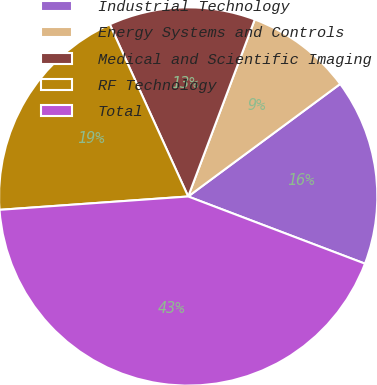Convert chart. <chart><loc_0><loc_0><loc_500><loc_500><pie_chart><fcel>Industrial Technology<fcel>Energy Systems and Controls<fcel>Medical and Scientific Imaging<fcel>RF Technology<fcel>Total<nl><fcel>15.92%<fcel>9.13%<fcel>12.53%<fcel>19.32%<fcel>43.09%<nl></chart> 